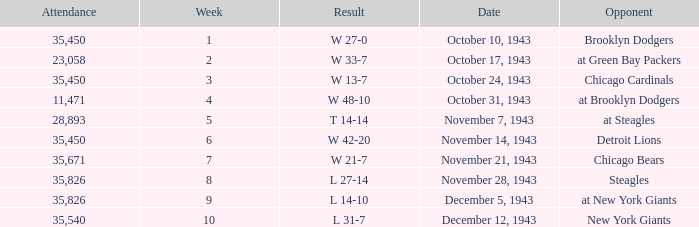How many attendances have 9 as the week? 1.0. 